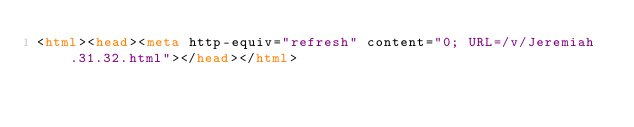<code> <loc_0><loc_0><loc_500><loc_500><_HTML_><html><head><meta http-equiv="refresh" content="0; URL=/v/Jeremiah.31.32.html"></head></html></code> 